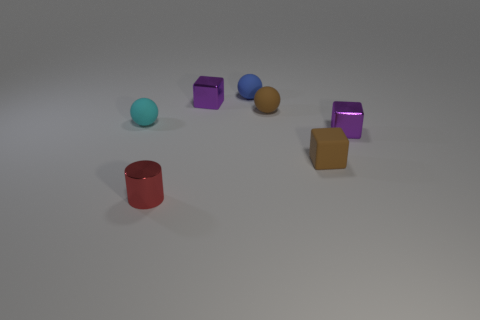What is the shape of the cyan object that is the same material as the blue sphere?
Provide a succinct answer. Sphere. Are there any other things that have the same color as the metal cylinder?
Give a very brief answer. No. Is the number of purple metal cubes that are to the left of the cyan rubber thing greater than the number of cyan balls that are behind the brown rubber cube?
Your answer should be very brief. No. What number of purple metal cubes are the same size as the cyan rubber thing?
Your response must be concise. 2. Is the number of small cyan matte balls in front of the cyan object less than the number of shiny cylinders that are behind the tiny metal cylinder?
Make the answer very short. No. Is there a brown object that has the same shape as the blue matte thing?
Offer a terse response. Yes. Do the red object and the blue object have the same shape?
Ensure brevity in your answer.  No. What number of big objects are purple metal cubes or shiny cylinders?
Ensure brevity in your answer.  0. Is the number of brown rubber balls greater than the number of purple blocks?
Provide a short and direct response. No. What size is the blue object that is the same material as the cyan sphere?
Make the answer very short. Small. 